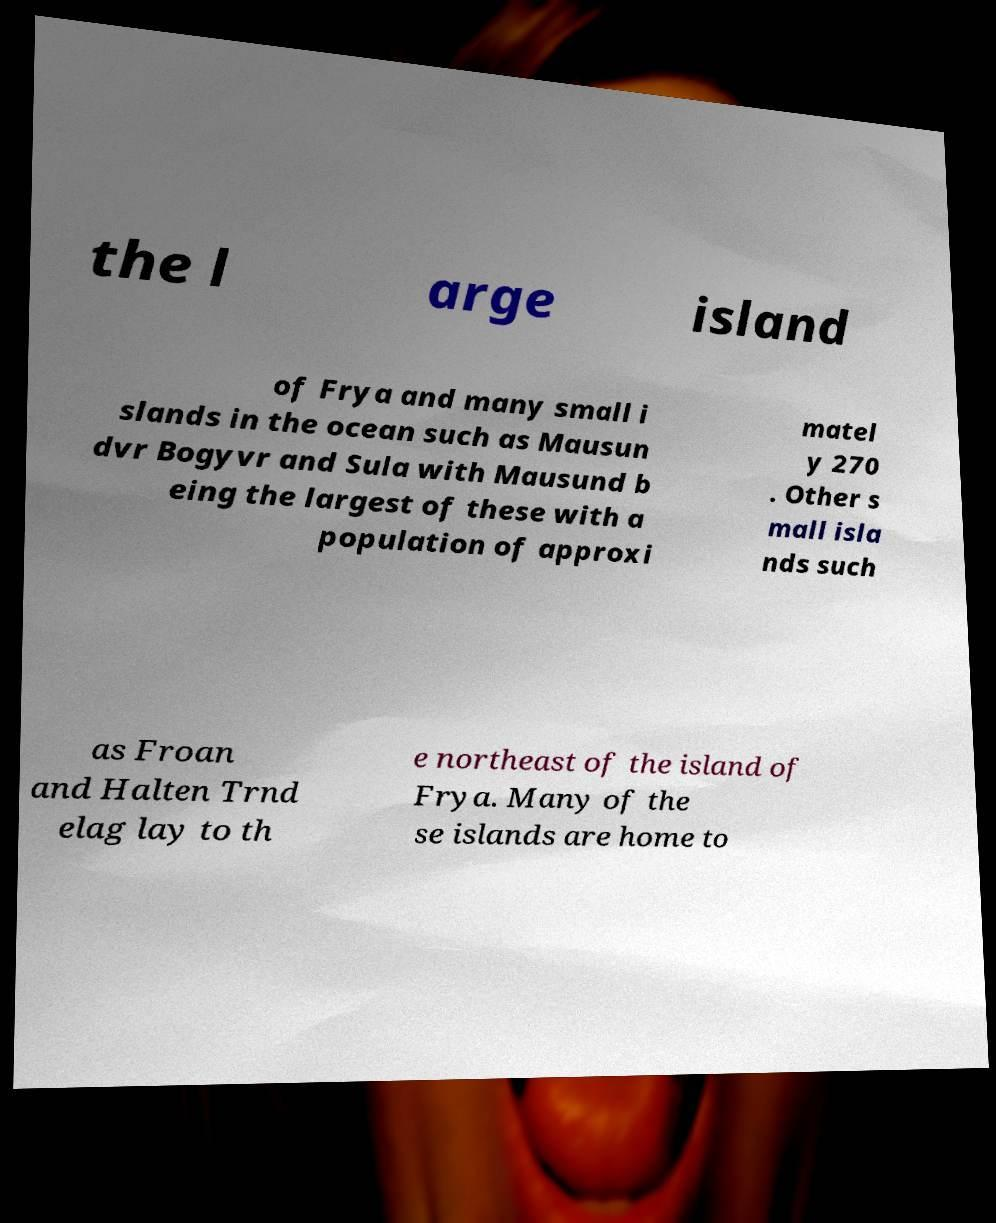There's text embedded in this image that I need extracted. Can you transcribe it verbatim? the l arge island of Frya and many small i slands in the ocean such as Mausun dvr Bogyvr and Sula with Mausund b eing the largest of these with a population of approxi matel y 270 . Other s mall isla nds such as Froan and Halten Trnd elag lay to th e northeast of the island of Frya. Many of the se islands are home to 